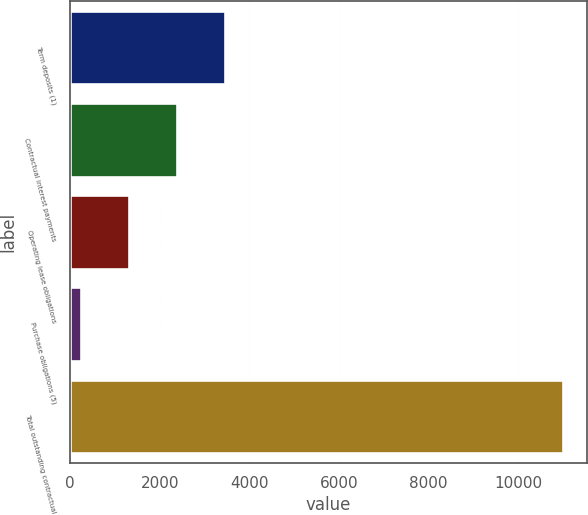Convert chart to OTSL. <chart><loc_0><loc_0><loc_500><loc_500><bar_chart><fcel>Term deposits (1)<fcel>Contractual interest payments<fcel>Operating lease obligations<fcel>Purchase obligations (5)<fcel>Total outstanding contractual<nl><fcel>3462.7<fcel>2386.8<fcel>1310.9<fcel>235<fcel>10994<nl></chart> 